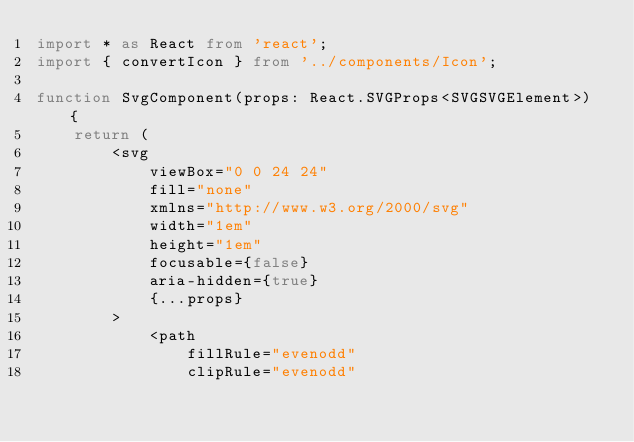Convert code to text. <code><loc_0><loc_0><loc_500><loc_500><_TypeScript_>import * as React from 'react';
import { convertIcon } from '../components/Icon';

function SvgComponent(props: React.SVGProps<SVGSVGElement>) {
    return (
        <svg
            viewBox="0 0 24 24"
            fill="none"
            xmlns="http://www.w3.org/2000/svg"
            width="1em"
            height="1em"
            focusable={false}
            aria-hidden={true}
            {...props}
        >
            <path
                fillRule="evenodd"
                clipRule="evenodd"</code> 